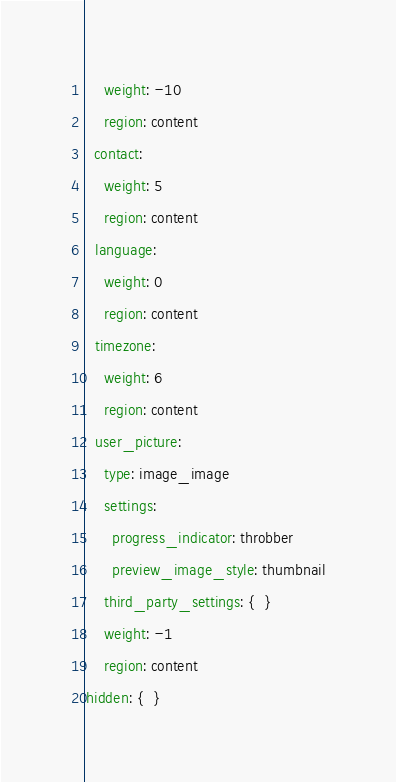Convert code to text. <code><loc_0><loc_0><loc_500><loc_500><_YAML_>    weight: -10
    region: content
  contact:
    weight: 5
    region: content
  language:
    weight: 0
    region: content
  timezone:
    weight: 6
    region: content
  user_picture:
    type: image_image
    settings:
      progress_indicator: throbber
      preview_image_style: thumbnail
    third_party_settings: {  }
    weight: -1
    region: content
hidden: {  }
</code> 